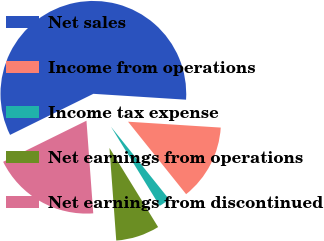Convert chart. <chart><loc_0><loc_0><loc_500><loc_500><pie_chart><fcel>Net sales<fcel>Income from operations<fcel>Income tax expense<fcel>Net earnings from operations<fcel>Net earnings from discontinued<nl><fcel>58.3%<fcel>13.24%<fcel>1.98%<fcel>7.61%<fcel>18.87%<nl></chart> 